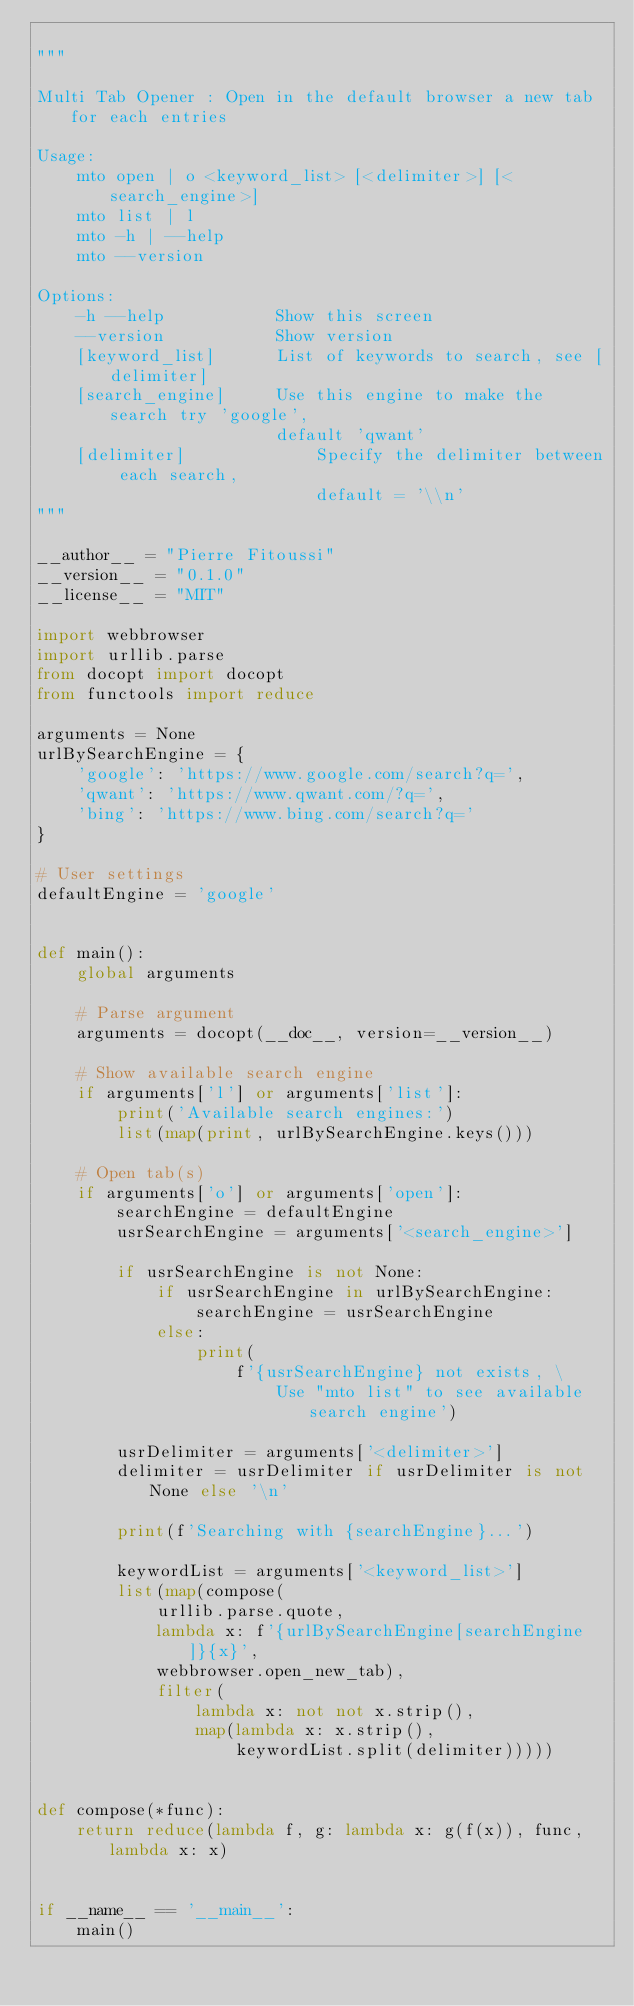<code> <loc_0><loc_0><loc_500><loc_500><_Python_>
"""

Multi Tab Opener : Open in the default browser a new tab for each entries

Usage:
    mto open | o <keyword_list> [<delimiter>] [<search_engine>]
    mto list | l
    mto -h | --help
    mto --version

Options:
    -h --help           Show this screen
    --version           Show version
    [keyword_list]      List of keywords to search, see [delimiter]
    [search_engine]     Use this engine to make the search try 'google',
                        default 'qwant'
    [delimiter]             Specify the delimiter between each search,
                            default = '\\n'
"""

__author__ = "Pierre Fitoussi"
__version__ = "0.1.0"
__license__ = "MIT"

import webbrowser
import urllib.parse
from docopt import docopt
from functools import reduce

arguments = None
urlBySearchEngine = {
    'google': 'https://www.google.com/search?q=',
    'qwant': 'https://www.qwant.com/?q=',
    'bing': 'https://www.bing.com/search?q='
}

# User settings
defaultEngine = 'google'


def main():
    global arguments

    # Parse argument
    arguments = docopt(__doc__, version=__version__)

    # Show available search engine
    if arguments['l'] or arguments['list']:
        print('Available search engines:')
        list(map(print, urlBySearchEngine.keys()))

    # Open tab(s)
    if arguments['o'] or arguments['open']:
        searchEngine = defaultEngine
        usrSearchEngine = arguments['<search_engine>']

        if usrSearchEngine is not None:
            if usrSearchEngine in urlBySearchEngine:
                searchEngine = usrSearchEngine
            else:
                print(
                    f'{usrSearchEngine} not exists, \
                        Use "mto list" to see available search engine')

        usrDelimiter = arguments['<delimiter>']
        delimiter = usrDelimiter if usrDelimiter is not None else '\n'

        print(f'Searching with {searchEngine}...')

        keywordList = arguments['<keyword_list>']
        list(map(compose(
            urllib.parse.quote,
            lambda x: f'{urlBySearchEngine[searchEngine]}{x}',
            webbrowser.open_new_tab),
            filter(
                lambda x: not not x.strip(),
                map(lambda x: x.strip(),
                    keywordList.split(delimiter)))))


def compose(*func):
    return reduce(lambda f, g: lambda x: g(f(x)), func, lambda x: x)


if __name__ == '__main__':
    main()
</code> 